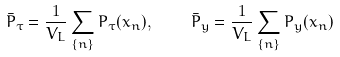Convert formula to latex. <formula><loc_0><loc_0><loc_500><loc_500>\bar { P } _ { \tau } = \frac { 1 } { V _ { L } } \sum _ { \{ n \} } P _ { \tau } ( x _ { n } ) , \quad \bar { P } _ { y } = \frac { 1 } { V _ { L } } \sum _ { \{ n \} } P _ { y } ( x _ { n } )</formula> 